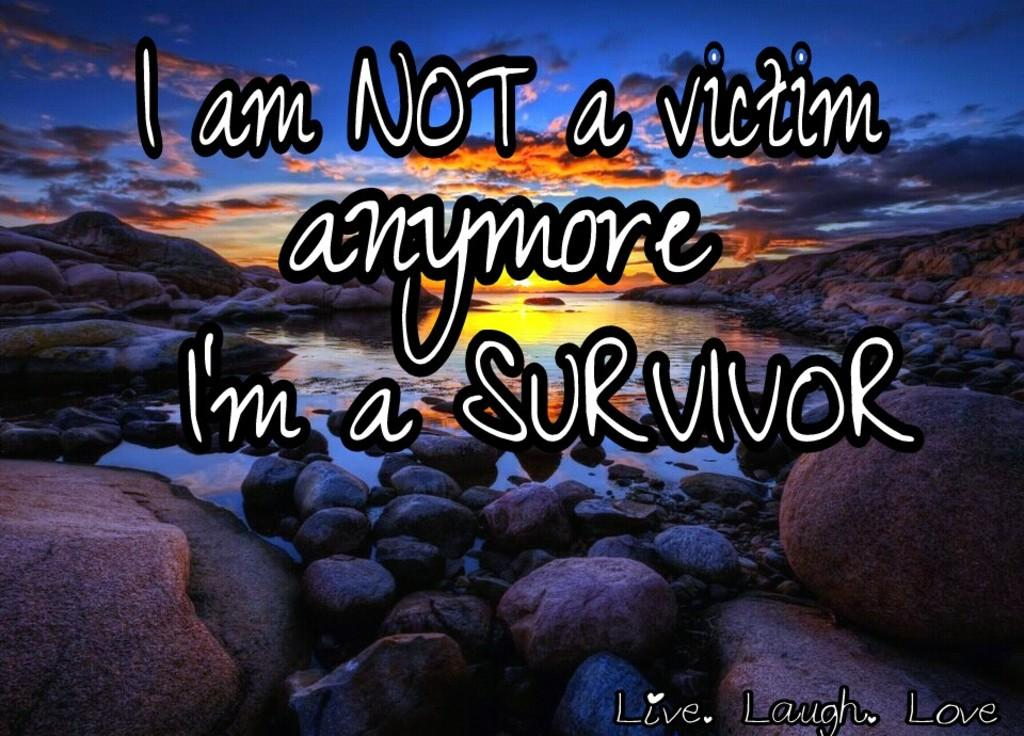<image>
Create a compact narrative representing the image presented. A quote says I am not a victim anymore, I'm a survivor. 